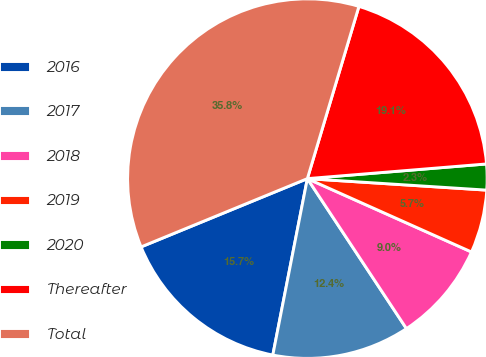Convert chart to OTSL. <chart><loc_0><loc_0><loc_500><loc_500><pie_chart><fcel>2016<fcel>2017<fcel>2018<fcel>2019<fcel>2020<fcel>Thereafter<fcel>Total<nl><fcel>15.72%<fcel>12.37%<fcel>9.02%<fcel>5.67%<fcel>2.32%<fcel>19.07%<fcel>35.83%<nl></chart> 